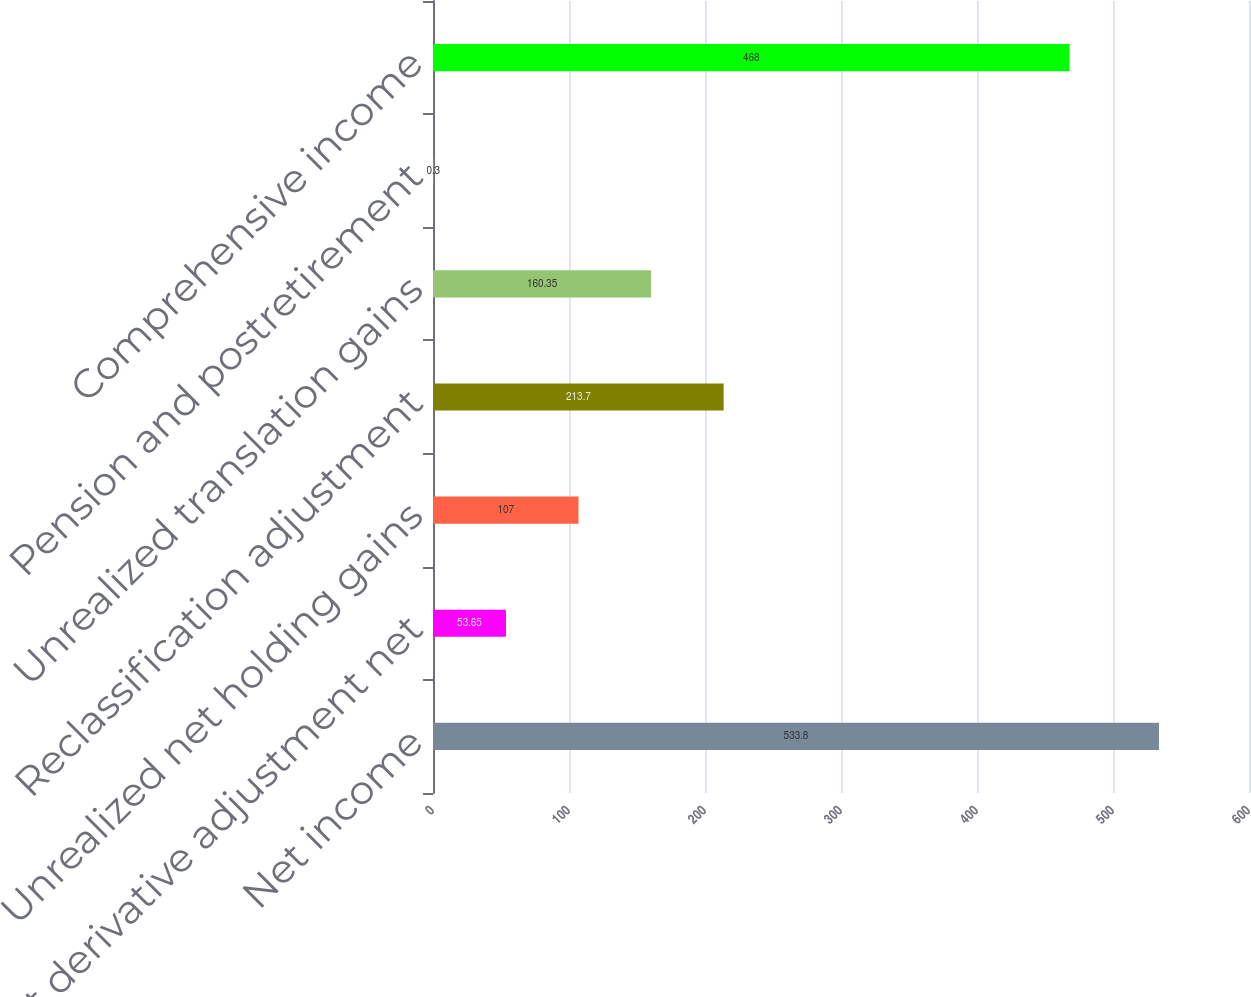Convert chart to OTSL. <chart><loc_0><loc_0><loc_500><loc_500><bar_chart><fcel>Net income<fcel>Net derivative adjustment net<fcel>Unrealized net holding gains<fcel>Reclassification adjustment<fcel>Unrealized translation gains<fcel>Pension and postretirement<fcel>Comprehensive income<nl><fcel>533.8<fcel>53.65<fcel>107<fcel>213.7<fcel>160.35<fcel>0.3<fcel>468<nl></chart> 